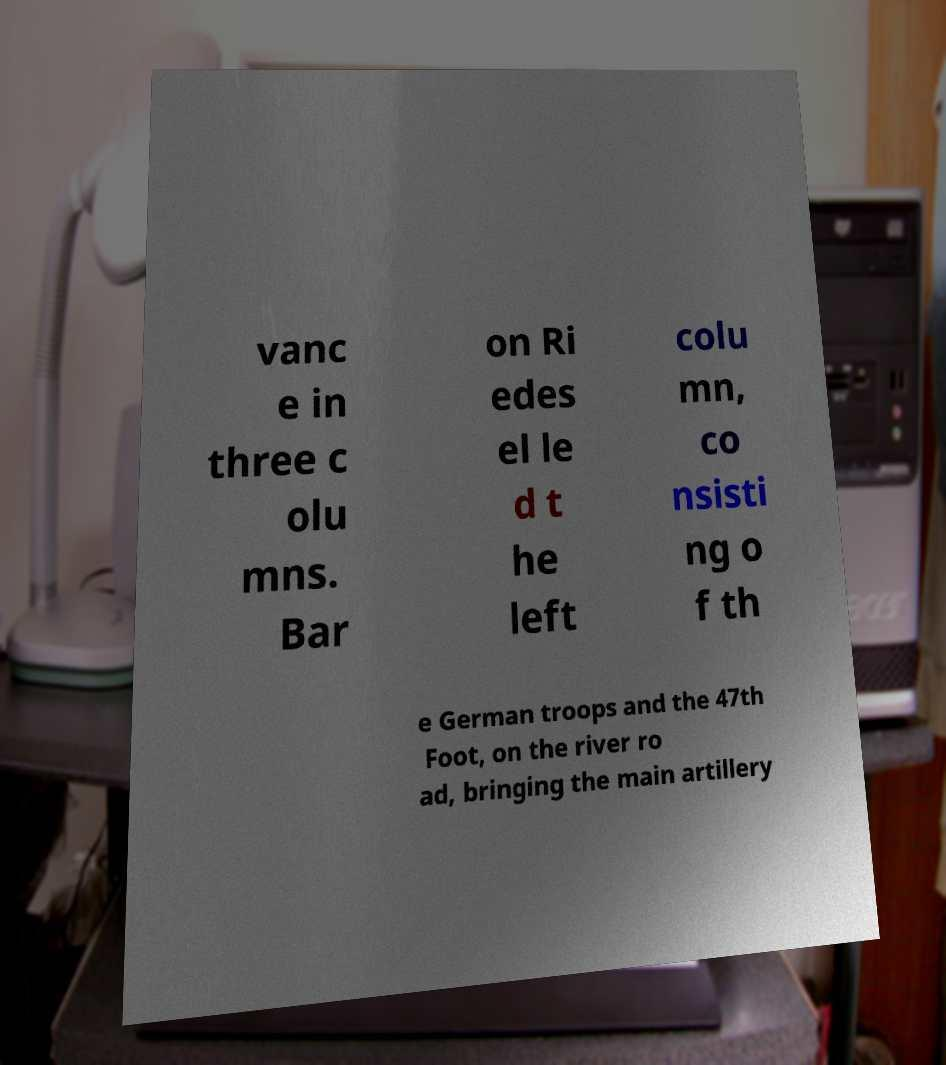Can you read and provide the text displayed in the image?This photo seems to have some interesting text. Can you extract and type it out for me? vanc e in three c olu mns. Bar on Ri edes el le d t he left colu mn, co nsisti ng o f th e German troops and the 47th Foot, on the river ro ad, bringing the main artillery 